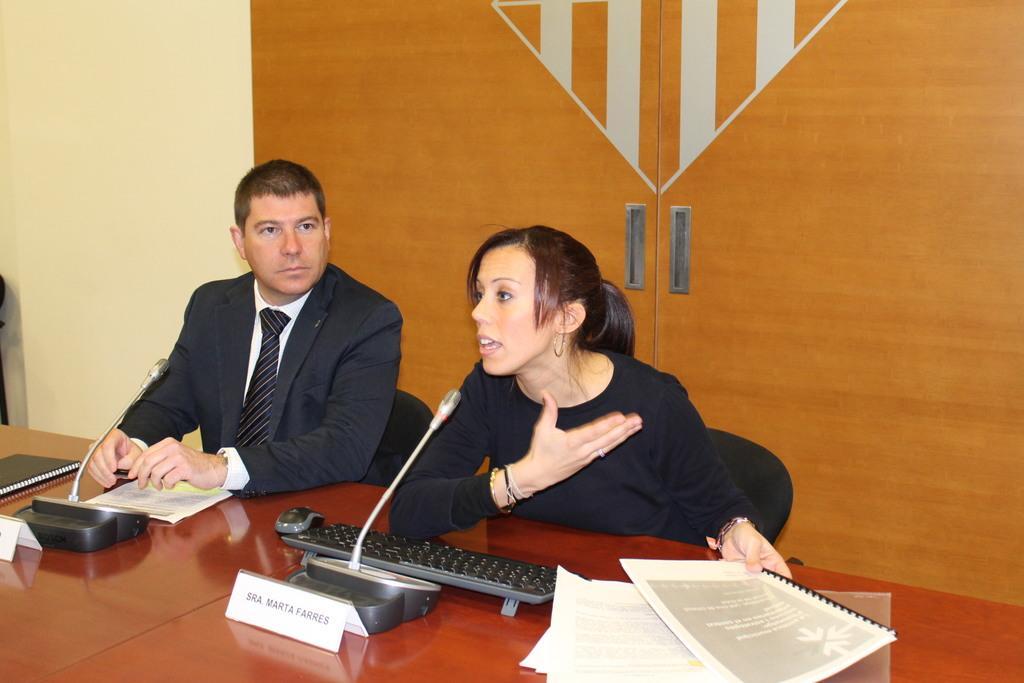Describe this image in one or two sentences. In this image I can see two people are sitting on chairs. I can see he is wearing formal dress and she is wearing black dress. Here on these tables I can see few white colour papers, few nameplates, few mics and I can see she is holding a book. I can also see a keyboard and a mouse over here. 